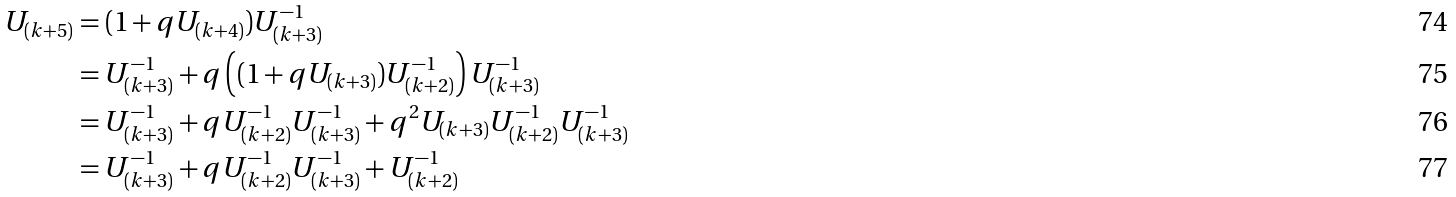<formula> <loc_0><loc_0><loc_500><loc_500>U _ { ( k + 5 ) } & = ( 1 + q U _ { ( k + 4 ) } ) U _ { ( k + 3 ) } ^ { - 1 } \\ & = U _ { ( k + 3 ) } ^ { - 1 } + q \left ( ( 1 + q U _ { ( k + 3 ) } ) U _ { ( k + 2 ) } ^ { - 1 } \right ) U _ { ( k + 3 ) } ^ { - 1 } \\ & = U _ { ( k + 3 ) } ^ { - 1 } + q U _ { ( k + 2 ) } ^ { - 1 } U _ { ( k + 3 ) } ^ { - 1 } + q ^ { 2 } U _ { ( k + 3 ) } U _ { ( k + 2 ) } ^ { - 1 } U _ { ( k + 3 ) } ^ { - 1 } \\ & = U _ { ( k + 3 ) } ^ { - 1 } + q U _ { ( k + 2 ) } ^ { - 1 } U _ { ( k + 3 ) } ^ { - 1 } + U _ { ( k + 2 ) } ^ { - 1 }</formula> 